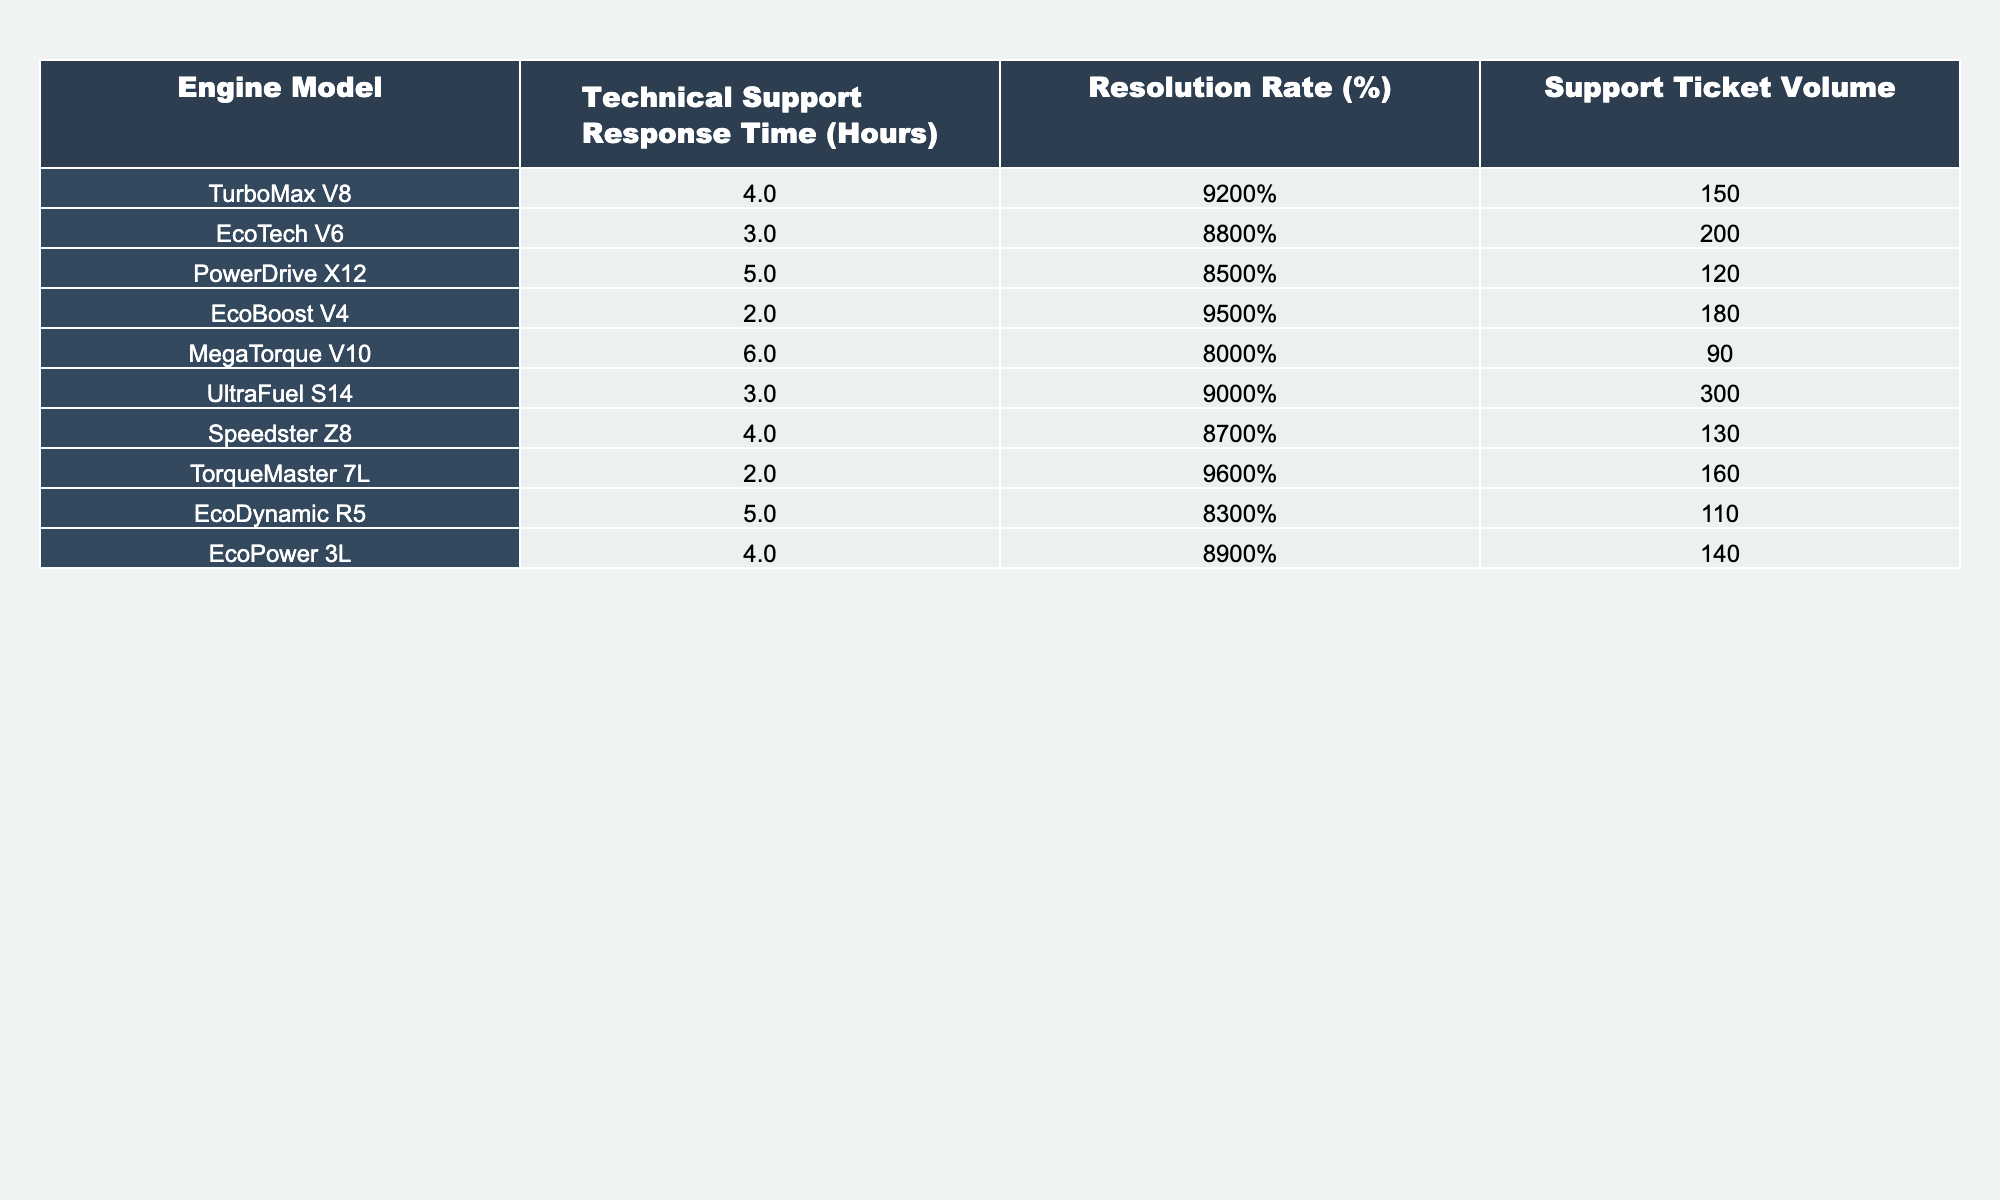What is the response time for the EcoBoost V4 engine model? The table lists the response time for EcoBoost V4 as 2 hours.
Answer: 2 hours Which engine model has the highest resolution rate? By reviewing the resolution rates, TorqueMaster 7L has the highest resolution rate at 96%.
Answer: TorqueMaster 7L What is the total support ticket volume for all engine models? Adding the support ticket volumes: 150 + 200 + 120 + 180 + 90 + 300 + 130 + 160 + 110 = 1,530.
Answer: 1530 What is the average response time for all engine models? To find the average, sum response times (4 + 3 + 5 + 2 + 6 + 3 + 4 + 2 + 5 + 4 = 43) and divide by the number of models (10): 43 / 10 = 4.3 hours.
Answer: 4.3 hours Is the resolution rate for PowerDrive X12 engine model above 80%? The resolution rate for PowerDrive X12 is 85%, which is above 80%.
Answer: Yes Which engine models have a response time of 4 hours? The engine models with a 4-hour response time are TurboMax V8, Speedster Z8, and EcoPower 3L.
Answer: TurboMax V8, Speedster Z8, EcoPower 3L What is the difference between the highest and lowest resolution rates? The highest resolution rate is 96% (TorqueMaster 7L) and the lowest is 80% (MegaTorque V10), so the difference is 96% - 80% = 16%.
Answer: 16% How many engine models have a resolution rate of 90% or higher? The models that meet this criterion are EcoBoost V4, TorqueMaster 7L, UltraFuel S14, and TurboMax V8, totaling four models.
Answer: 4 Is the EcoTech V6 more efficient than the EcoPower 3L in terms of resolution rate? EcoTech V6 has a resolution rate of 88%, while EcoPower 3L has 89%, making EcoPower 3L more efficient.
Answer: No What is the average resolution rate for engine models with a response time of 3 hours? The only models with 3-hour response times are EcoTech V6, UltraFuel S14, and Speedster Z8, with rates of 88%, 90%, and 87%, respectively. Average = (88% + 90% + 87%) / 3 = 88.33%.
Answer: 88.33% 